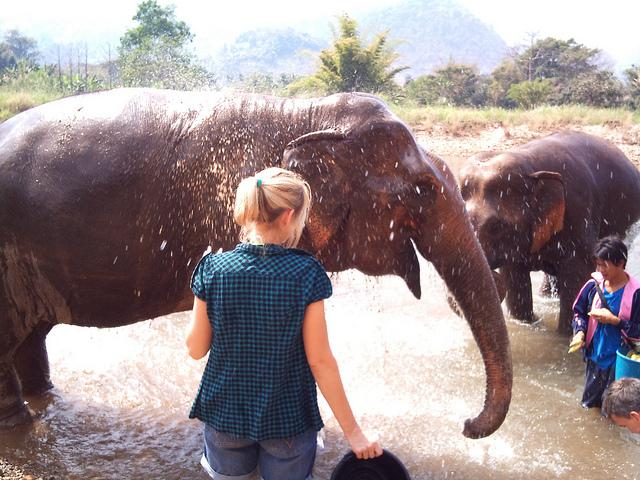Which part of the Elephant's body work to cool their body? Please explain your reasoning. trunk. They pick up water and throw it back 